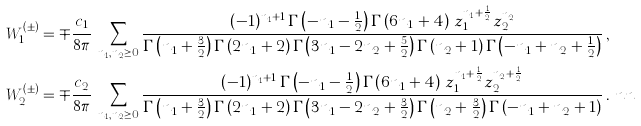Convert formula to latex. <formula><loc_0><loc_0><loc_500><loc_500>W _ { 1 } ^ { ( \pm ) } & = \mp \frac { c _ { 1 } } { 8 \pi } \, \sum _ { n _ { 1 } , n _ { 2 } \geq 0 } \frac { ( - 1 ) ^ { n _ { 1 } + 1 } \, \Gamma \left ( - n _ { 1 } - \frac { 1 } { 2 } \right ) \Gamma \left ( 6 n _ { 1 } + 4 \right ) \, z _ { 1 } ^ { n _ { 1 } + \frac { 1 } { 2 } } z _ { 2 } ^ { n _ { 2 } } } { \Gamma \left ( n _ { 1 } + \frac { 3 } { 2 } \right ) \Gamma \left ( 2 n _ { 1 } + 2 \right ) \Gamma \left ( 3 n _ { 1 } - 2 n _ { 2 } + \frac { 5 } { 2 } \right ) \Gamma \left ( n _ { 2 } + 1 \right ) \Gamma \left ( - n _ { 1 } + n _ { 2 } + \frac { 1 } { 2 } \right ) } \, , \\ W _ { 2 } ^ { ( \pm ) } & = \mp \frac { c _ { 2 } } { 8 \pi } \, \sum _ { n _ { 1 } , n _ { 2 } \geq 0 } \frac { ( - 1 ) ^ { n _ { 1 } + 1 } \, \Gamma \left ( - n _ { 1 } - \frac { 1 } { 2 } \right ) \Gamma \left ( 6 n _ { 1 } + 4 \right ) \, z _ { 1 } ^ { n _ { 1 } + \frac { 1 } { 2 } } z _ { 2 } ^ { n _ { 2 } + \frac { 1 } { 2 } } } { \Gamma \left ( n _ { 1 } + \frac { 3 } { 2 } \right ) \Gamma \left ( 2 n _ { 1 } + 2 \right ) \Gamma \left ( 3 n _ { 1 } - 2 n _ { 2 } + \frac { 3 } { 2 } \right ) \Gamma \left ( n _ { 2 } + \frac { 3 } { 2 } \right ) \Gamma \left ( - n _ { 1 } + n _ { 2 } + 1 \right ) } \, . \ n n</formula> 